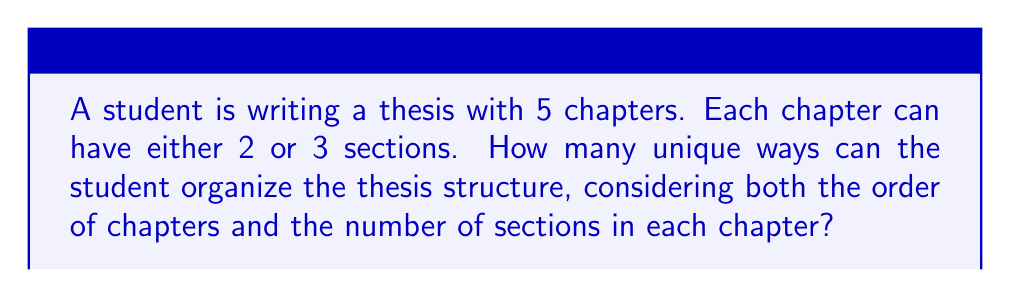Solve this math problem. Let's approach this step-by-step:

1) First, we need to consider the choices for each chapter. Each chapter can have either 2 or 3 sections, so there are 2 choices for each chapter.

2) Since there are 5 chapters, and each chapter has 2 choices independently, we can use the multiplication principle. The total number of ways to choose the number of sections for all chapters is:

   $$ 2 \times 2 \times 2 \times 2 \times 2 = 2^5 = 32 $$

3) Now, for each of these 32 possibilities, we need to consider the order of the chapters. The order of the 5 chapters can be arranged in 5! ways.

4) By the multiplication principle, the total number of unique ways to organize the thesis structure is:

   $$ 32 \times 5! = 32 \times 120 = 3840 $$

This accounts for both the number of sections in each chapter and the order of the chapters.
Answer: 3840 